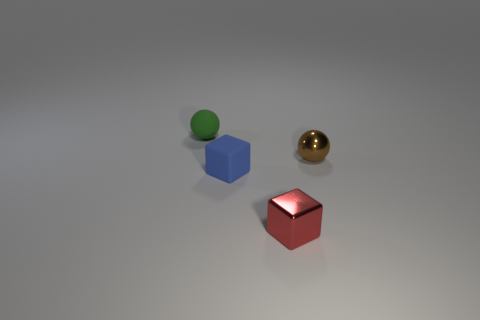What could be the possible materials of these objects based on their appearance? The objects seem to possess different materials. The green sphere has a matte finish suggesting it could be made of rubber or plastic. The blue cube has a slightly reflective surface that might be indicative of painted wood or hard plastic. Lastly, the golden sphere's reflective, shiny surface indicates it could be a metal, such as polished brass or gold. 